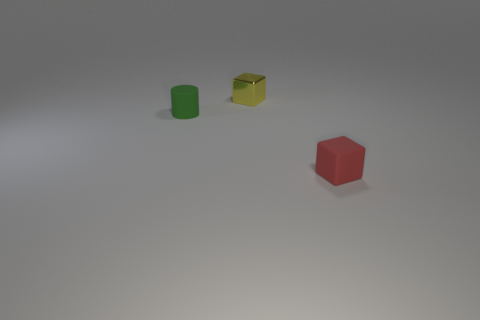Can you describe the lighting and shadows seen in the image? The image features a soft, diffused light that casts gentle shadows beneath each of the three objects. These shadows are slightly elongated, which implies that the light source, while not visible, is positioned at a moderate angle to the objects. 